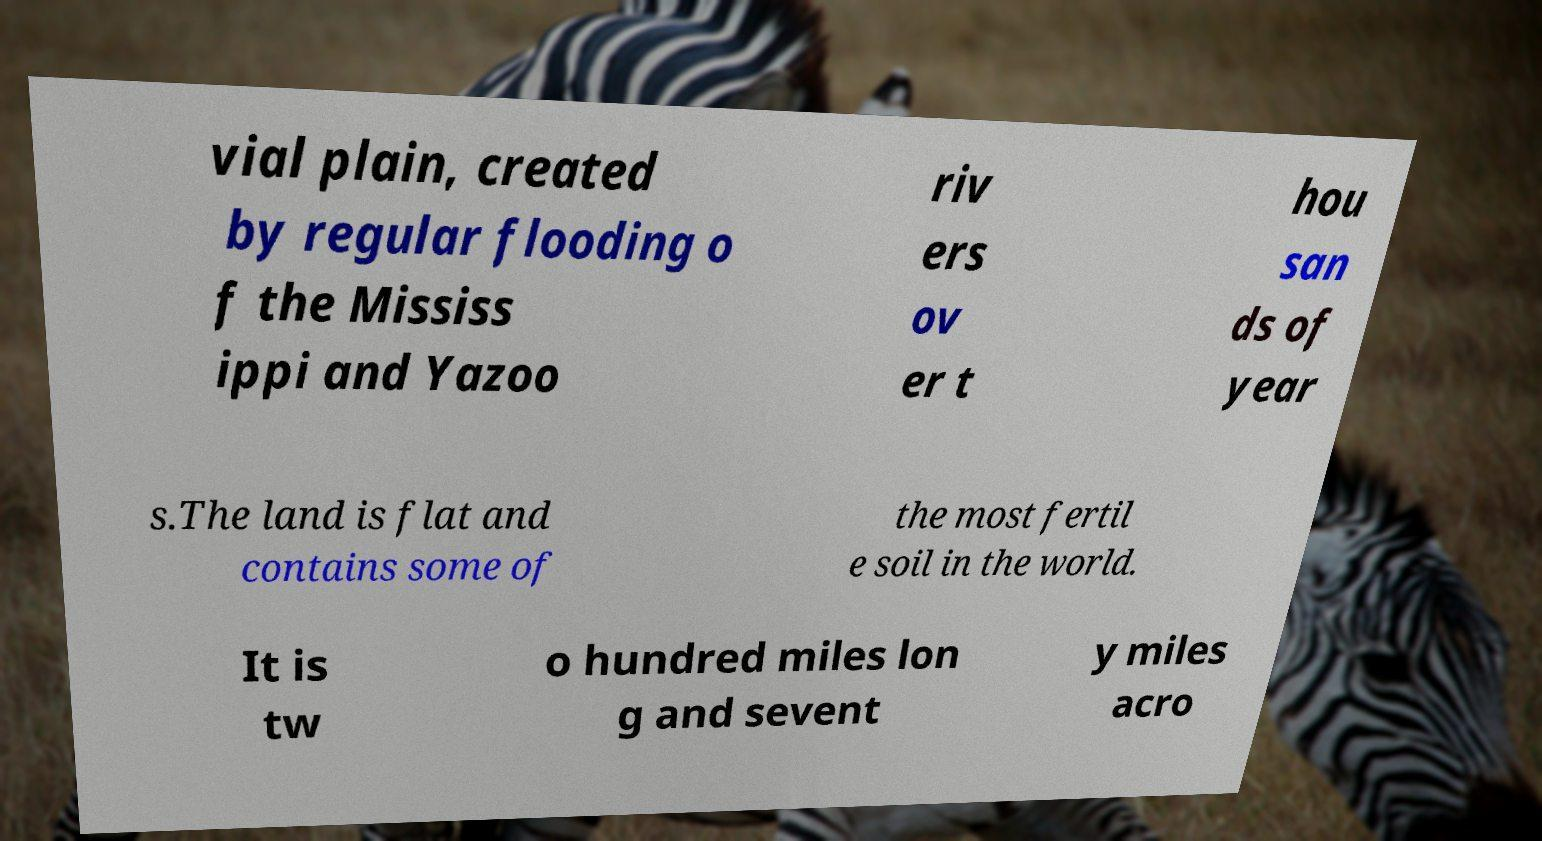Could you extract and type out the text from this image? vial plain, created by regular flooding o f the Mississ ippi and Yazoo riv ers ov er t hou san ds of year s.The land is flat and contains some of the most fertil e soil in the world. It is tw o hundred miles lon g and sevent y miles acro 